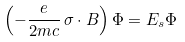<formula> <loc_0><loc_0><loc_500><loc_500>\left ( - \frac { e } { 2 m c } \, \sigma \cdot B \right ) \Phi = E _ { s } \Phi</formula> 